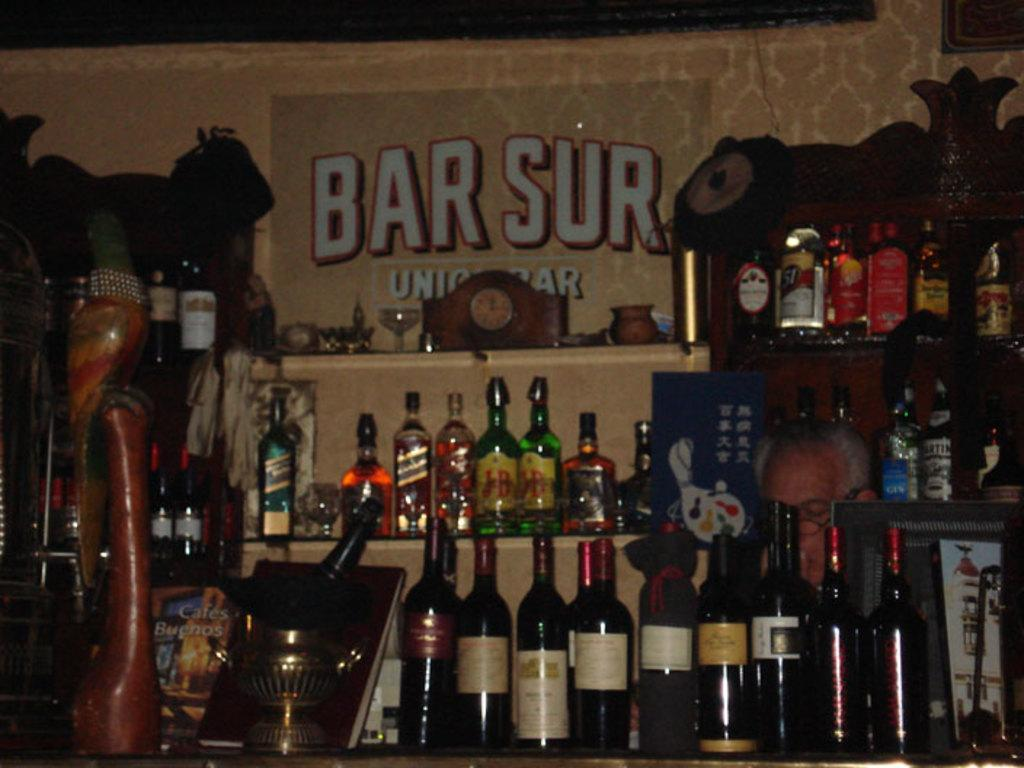<image>
Offer a succinct explanation of the picture presented. Bar front with many bottles and the word "BAR SUR" in the back. 